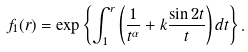<formula> <loc_0><loc_0><loc_500><loc_500>f _ { 1 } ( r ) = \exp \left \{ \int _ { 1 } ^ { r } \left ( \frac { 1 } { t ^ { \alpha } } + k \frac { \sin 2 t } { t } \right ) d t \right \} .</formula> 